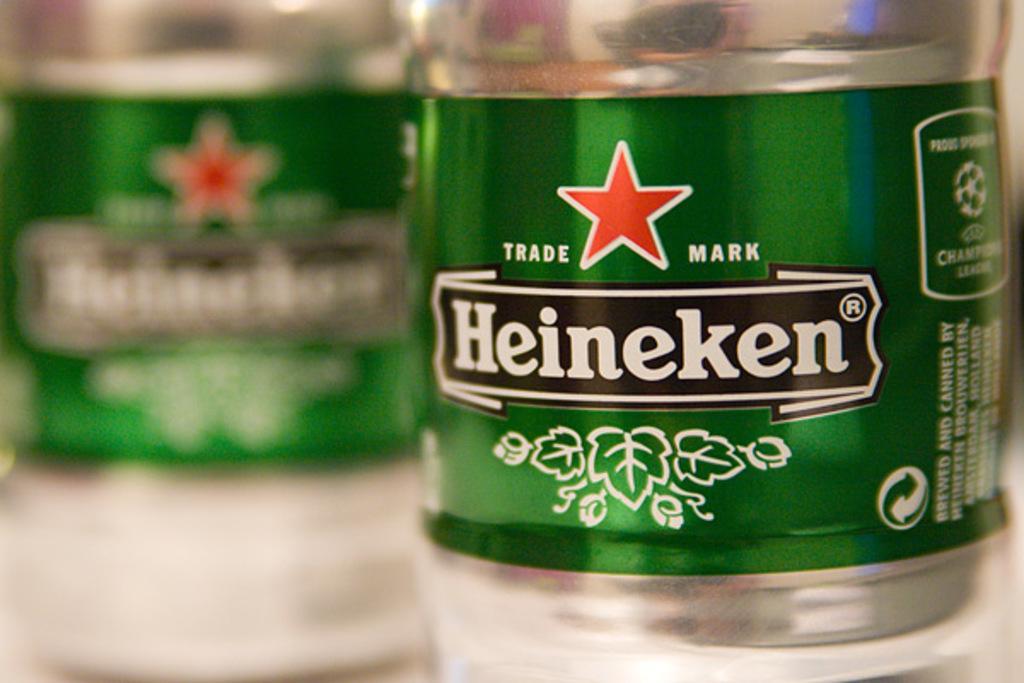Describe this image in one or two sentences. In this image we can see a bottle with a label written Heineken on it. On the left side we can also see another bottle which is slightly blurred. 